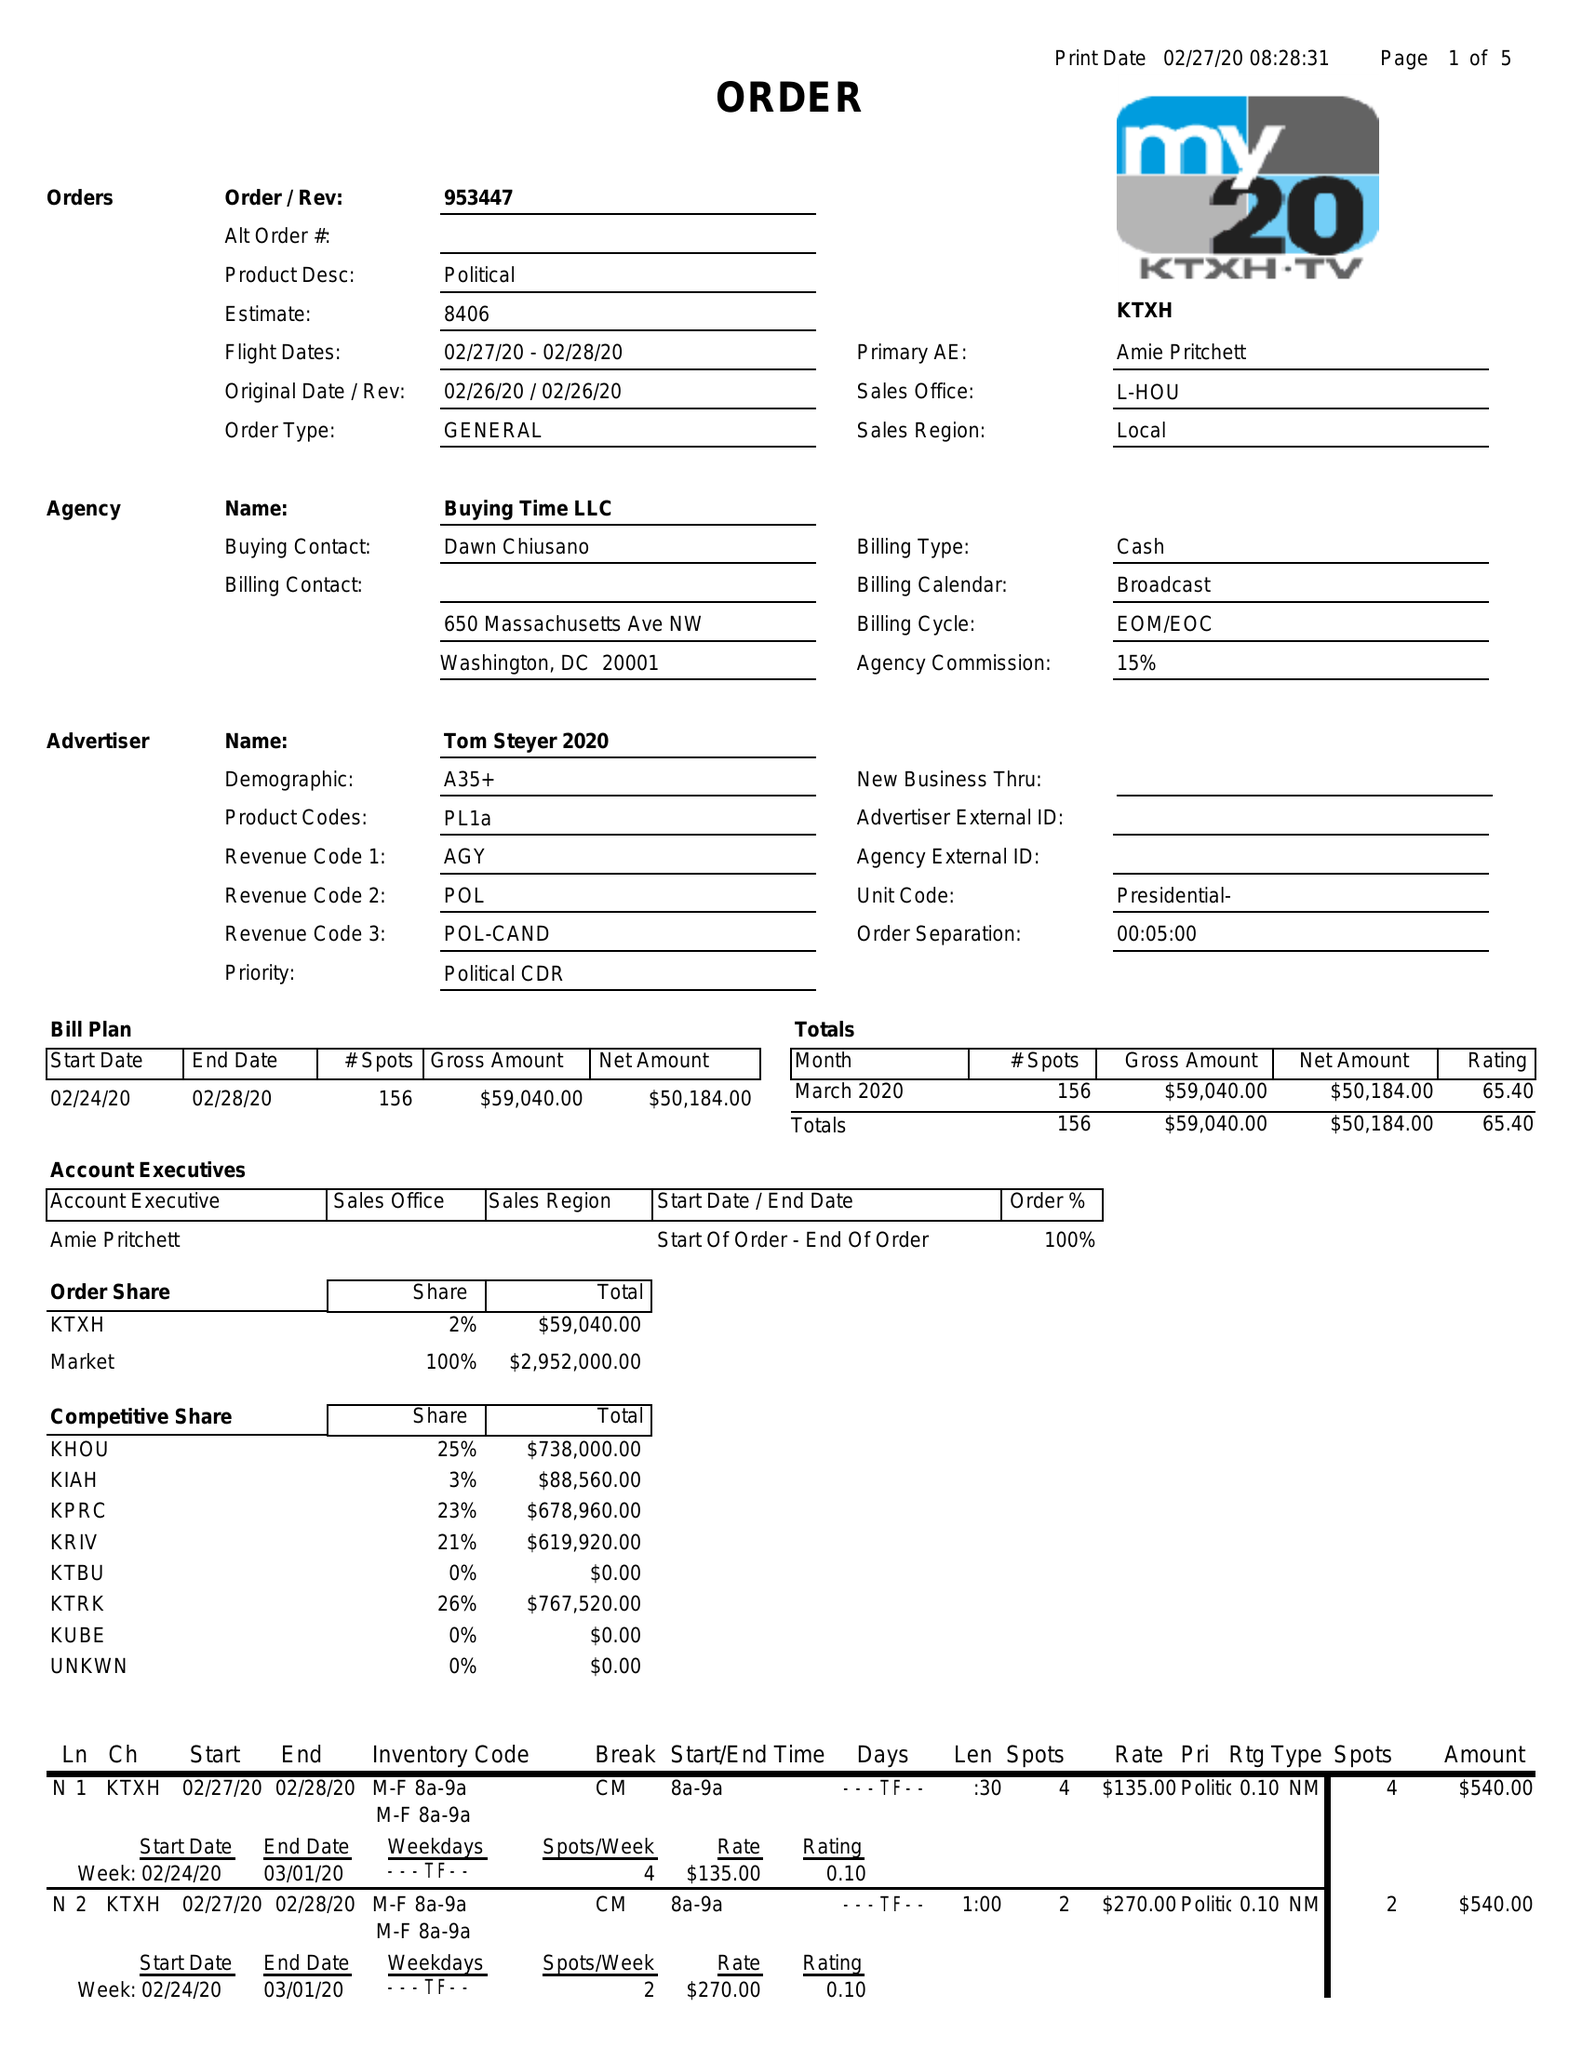What is the value for the gross_amount?
Answer the question using a single word or phrase. 59040.00 